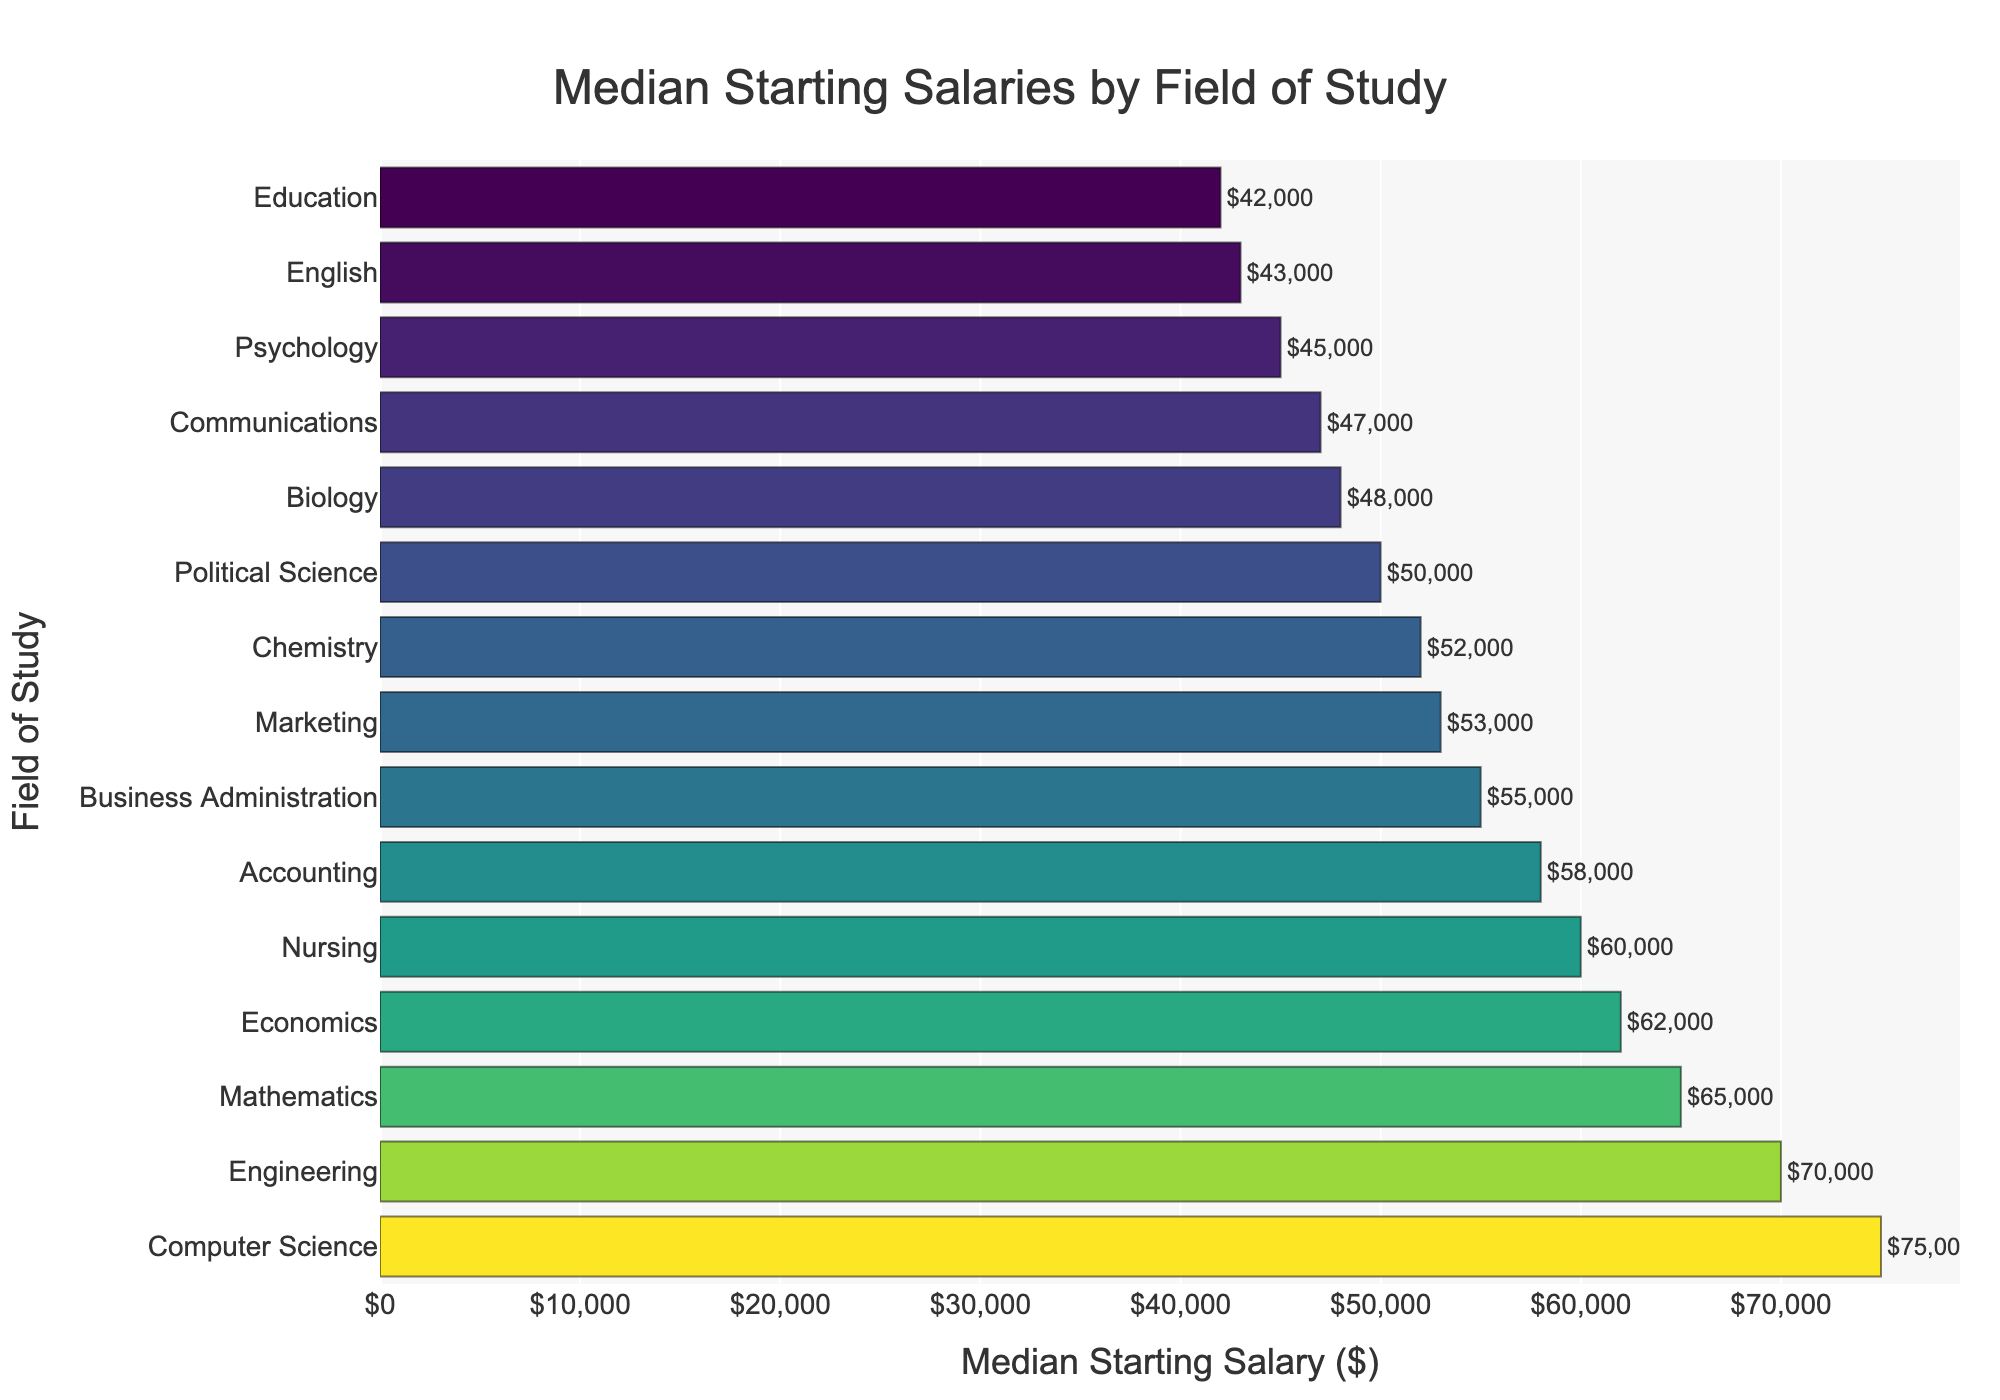What is the title of the figure? The title of the figure is written at the top of the chart and it states "Median Starting Salaries by Field of Study"
Answer: Median Starting Salaries by Field of Study Which field of study has the highest median starting salary? The highest bar represents the highest median starting salary, which is 75000. The corresponding field of study at the y-axis is "Computer Science"
Answer: Computer Science What are the median starting salaries for fields in Business Administration and Marketing? Locate the bars corresponding to Business Administration and Marketing. Business Administration has a median starting salary of 55000 and Marketing has 53000.
Answer: Business Administration: 55000, Marketing: 53000 What is the median starting salary difference between Engineering and Nursing? Engineering has a median starting salary of 70000 and Nursing has 60000. The difference is calculated as 70000 - 60000
Answer: 10000 How many fields of study have a median starting salary of at least 60000? Count all the bars that meet or exceed 60000 in height. They are Computer Science, Engineering, Mathematics, Nursing, and Economics.
Answer: 5 What is the median starting salary for Psychology? Locate the bar for Psychology which has a median starting salary of 45000 as listed in the chart.
Answer: 45000 Is the median starting salary for Biology higher or lower than Chemistry? Compare the heights of the bars for Biology and Chemistry. Biology has a median starting salary of 48000 and Chemistry has 52000. Biology is lower.
Answer: Lower What is the average median starting salary of Accounting, Political Science, and English? Sum the median starting salaries for Accounting (58000), Political Science (50000), and English (43000), then divide by 3. (58000 + 50000 + 43000) / 3 = 50333.33
Answer: 50333.33 Which fields of study have median starting salaries between 50000 and 60000? Look for bars within the range 50000 and 60000. Fields include Accounting (58000), Political Science (50000), Chemistry (52000), and Marketing (53000).
Answer: Accounting, Political Science, Chemistry, Marketing Which fields have a median starting salary lower than Communications? Communications has a median starting salary of 47000. Fields with lower salaries include Education (42000), English (43000), and Psychology (45000).
Answer: Education, English, Psychology 